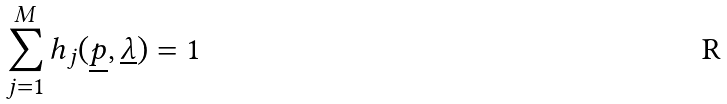<formula> <loc_0><loc_0><loc_500><loc_500>\sum _ { j = 1 } ^ { M } h _ { j } ( \underline { p } , \underline { \lambda } ) = 1</formula> 